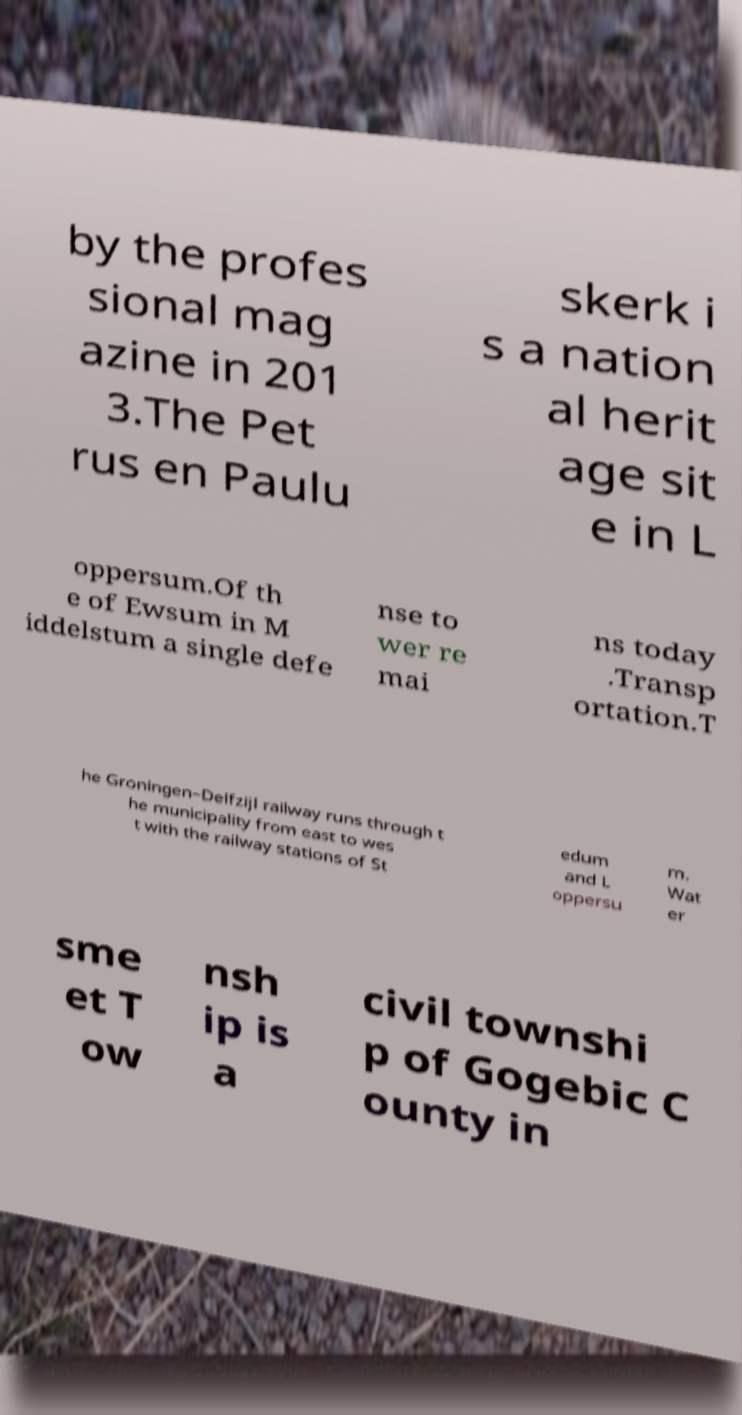Please read and relay the text visible in this image. What does it say? by the profes sional mag azine in 201 3.The Pet rus en Paulu skerk i s a nation al herit age sit e in L oppersum.Of th e of Ewsum in M iddelstum a single defe nse to wer re mai ns today .Transp ortation.T he Groningen–Delfzijl railway runs through t he municipality from east to wes t with the railway stations of St edum and L oppersu m. Wat er sme et T ow nsh ip is a civil townshi p of Gogebic C ounty in 